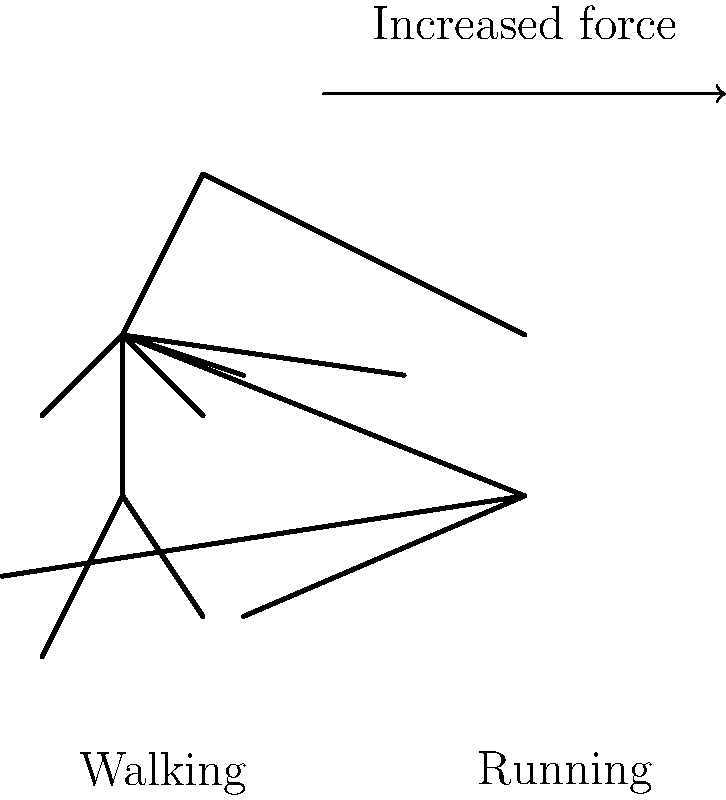As a keto diet influencer promoting an active lifestyle, you often discuss exercise. What is the primary biomechanical difference between running and walking that contributes to higher calorie burn in running, and how does this relate to the ground reaction force (GRF)? To understand the biomechanical differences between running and walking and their impact on calorie burn, let's break it down step-by-step:

1. Gait Cycle:
   - Walking: There's always at least one foot in contact with the ground.
   - Running: There's a "flight phase" where both feet are off the ground.

2. Ground Reaction Force (GRF):
   - Walking: The GRF typically reaches about 1-1.5 times body weight.
   - Running: The GRF can reach 2-3 times body weight due to the increased impact.

3. Center of Mass (COM) Movement:
   - Walking: The COM follows a smooth, sinusoidal path with minimal vertical displacement.
   - Running: The COM has a larger vertical displacement, leading to more work against gravity.

4. Energy Storage and Return:
   - Walking: Minimal elastic energy storage in tendons and ligaments.
   - Running: Significant elastic energy storage and return, especially in the Achilles tendon and arch of the foot.

5. Muscle Activation:
   - Walking: Lower overall muscle activation.
   - Running: Higher muscle activation, particularly in the lower limbs.

6. Metabolic Cost:
   - Running requires more energy due to the increased GRF, larger COM displacement, and higher muscle activation.

The primary biomechanical difference contributing to higher calorie burn in running is the increased GRF. This higher force requires more muscle activation and energy expenditure to propel the body forward and upward during the flight phase, resulting in greater calorie burn compared to walking.
Answer: Increased ground reaction force in running leads to higher muscle activation and energy expenditure. 